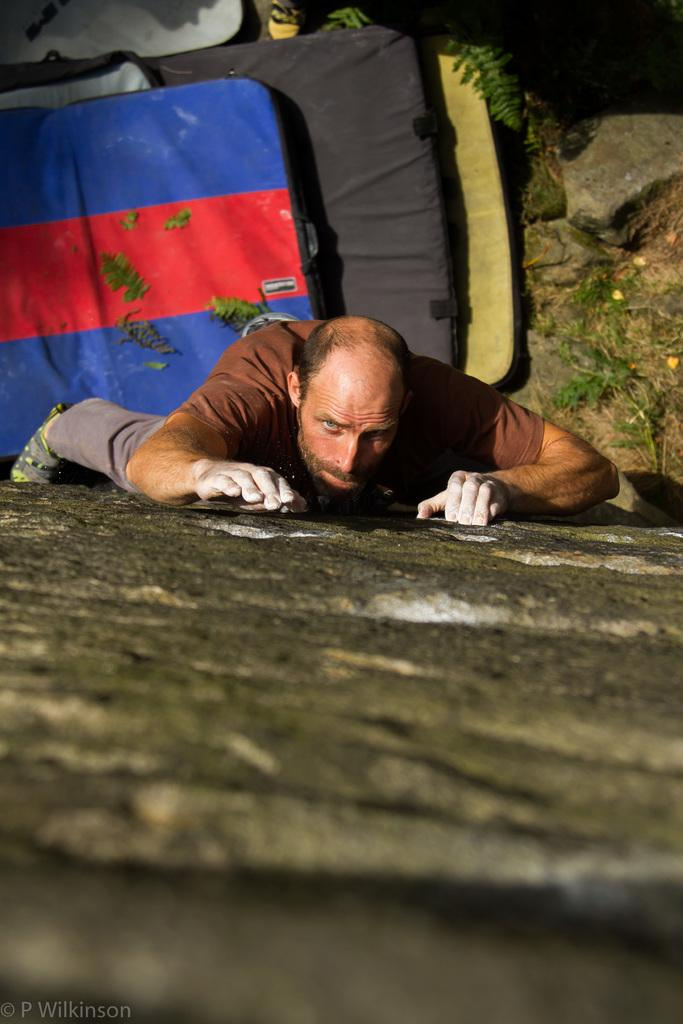What is the main activity being performed in the image? There is a person climbing a rock in the image. What objects are located at the bottom of the image? There are beds at the bottom of the image. Where can some text be found in the image? Some text can be found on the left side of the image. Can you see a swing in the image? No, there is no swing present in the image. What type of plant is growing near the person climbing the rock? There is no plant visible in the image. 